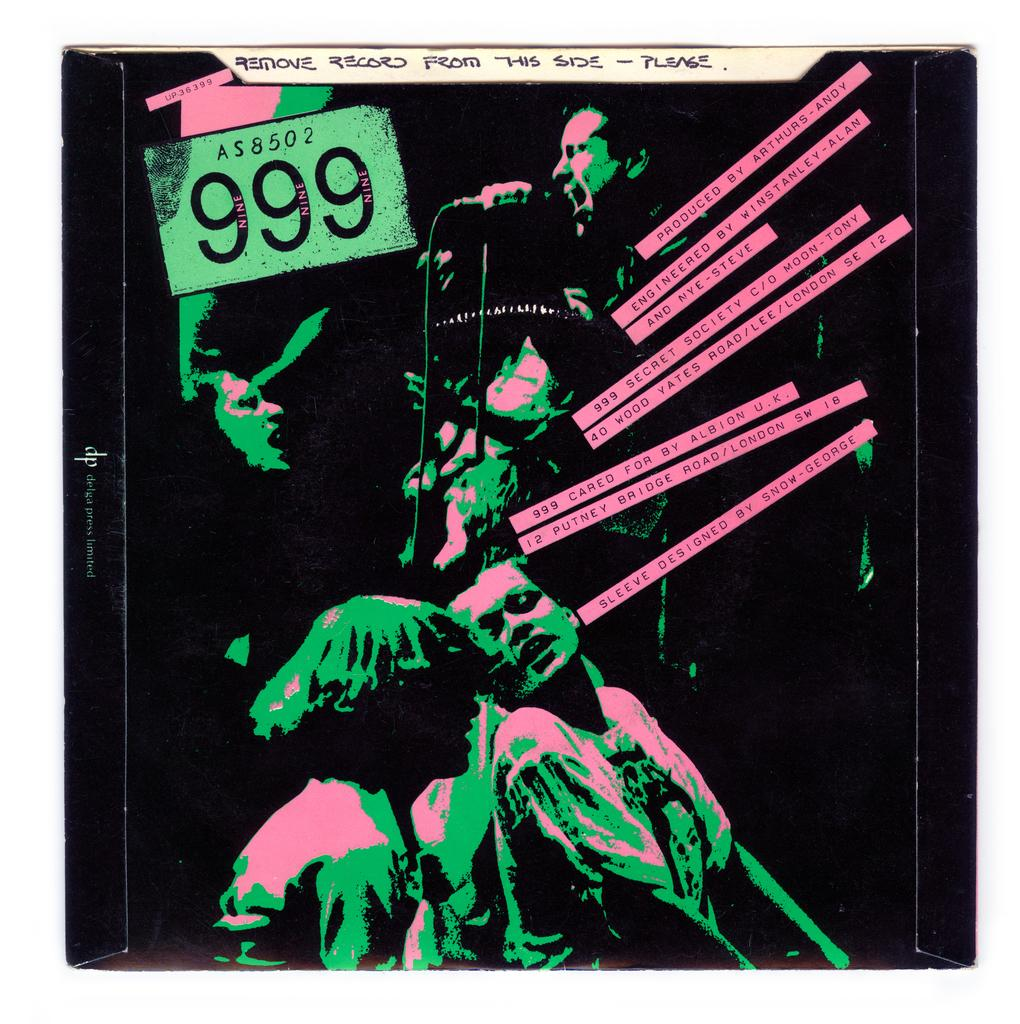Provide a one-sentence caption for the provided image. An album cover of a 999 record with a note saying "remove record from this side - please". 